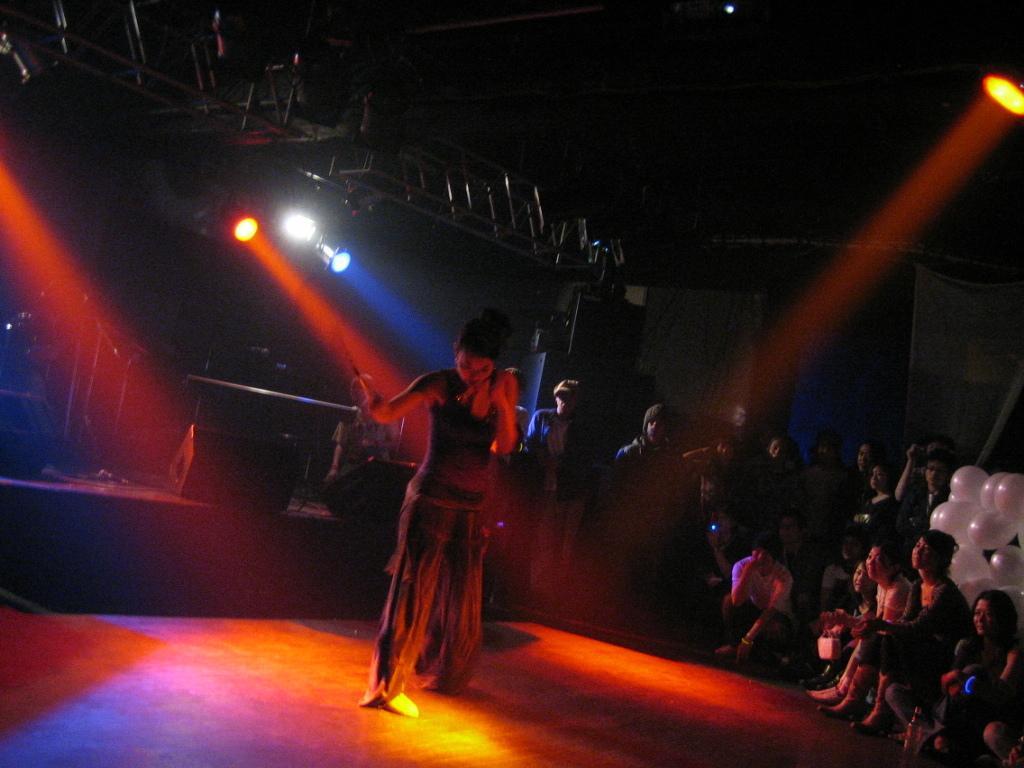In one or two sentences, can you explain what this image depicts? In this image I can see number of people where few are sitting and few are standing. I can also see few lights, few pink colour balloons and I can see this image is little bit in dark. 